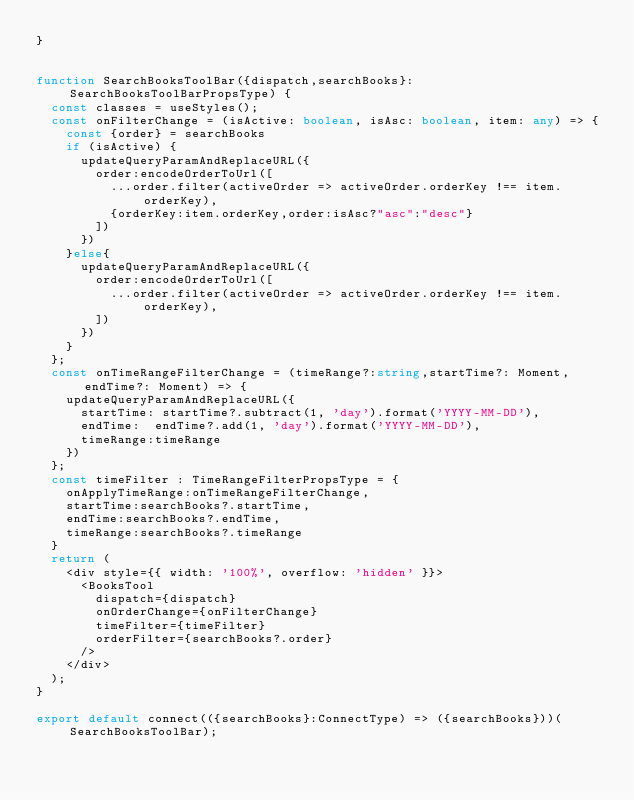<code> <loc_0><loc_0><loc_500><loc_500><_TypeScript_>}


function SearchBooksToolBar({dispatch,searchBooks}: SearchBooksToolBarPropsType) {
  const classes = useStyles();
  const onFilterChange = (isActive: boolean, isAsc: boolean, item: any) => {
    const {order} = searchBooks
    if (isActive) {
      updateQueryParamAndReplaceURL({
        order:encodeOrderToUrl([
          ...order.filter(activeOrder => activeOrder.orderKey !== item.orderKey),
          {orderKey:item.orderKey,order:isAsc?"asc":"desc"}
        ])
      })
    }else{
      updateQueryParamAndReplaceURL({
        order:encodeOrderToUrl([
          ...order.filter(activeOrder => activeOrder.orderKey !== item.orderKey),
        ])
      })
    }
  };
  const onTimeRangeFilterChange = (timeRange?:string,startTime?: Moment, endTime?: Moment) => {
    updateQueryParamAndReplaceURL({
      startTime: startTime?.subtract(1, 'day').format('YYYY-MM-DD'),
      endTime:  endTime?.add(1, 'day').format('YYYY-MM-DD'),
      timeRange:timeRange
    })
  };
  const timeFilter : TimeRangeFilterPropsType = {
    onApplyTimeRange:onTimeRangeFilterChange,
    startTime:searchBooks?.startTime,
    endTime:searchBooks?.endTime,
    timeRange:searchBooks?.timeRange
  }
  return (
    <div style={{ width: '100%', overflow: 'hidden' }}>
      <BooksTool
        dispatch={dispatch}
        onOrderChange={onFilterChange}
        timeFilter={timeFilter}
        orderFilter={searchBooks?.order}
      />
    </div>
  );
}

export default connect(({searchBooks}:ConnectType) => ({searchBooks}))(SearchBooksToolBar);
</code> 